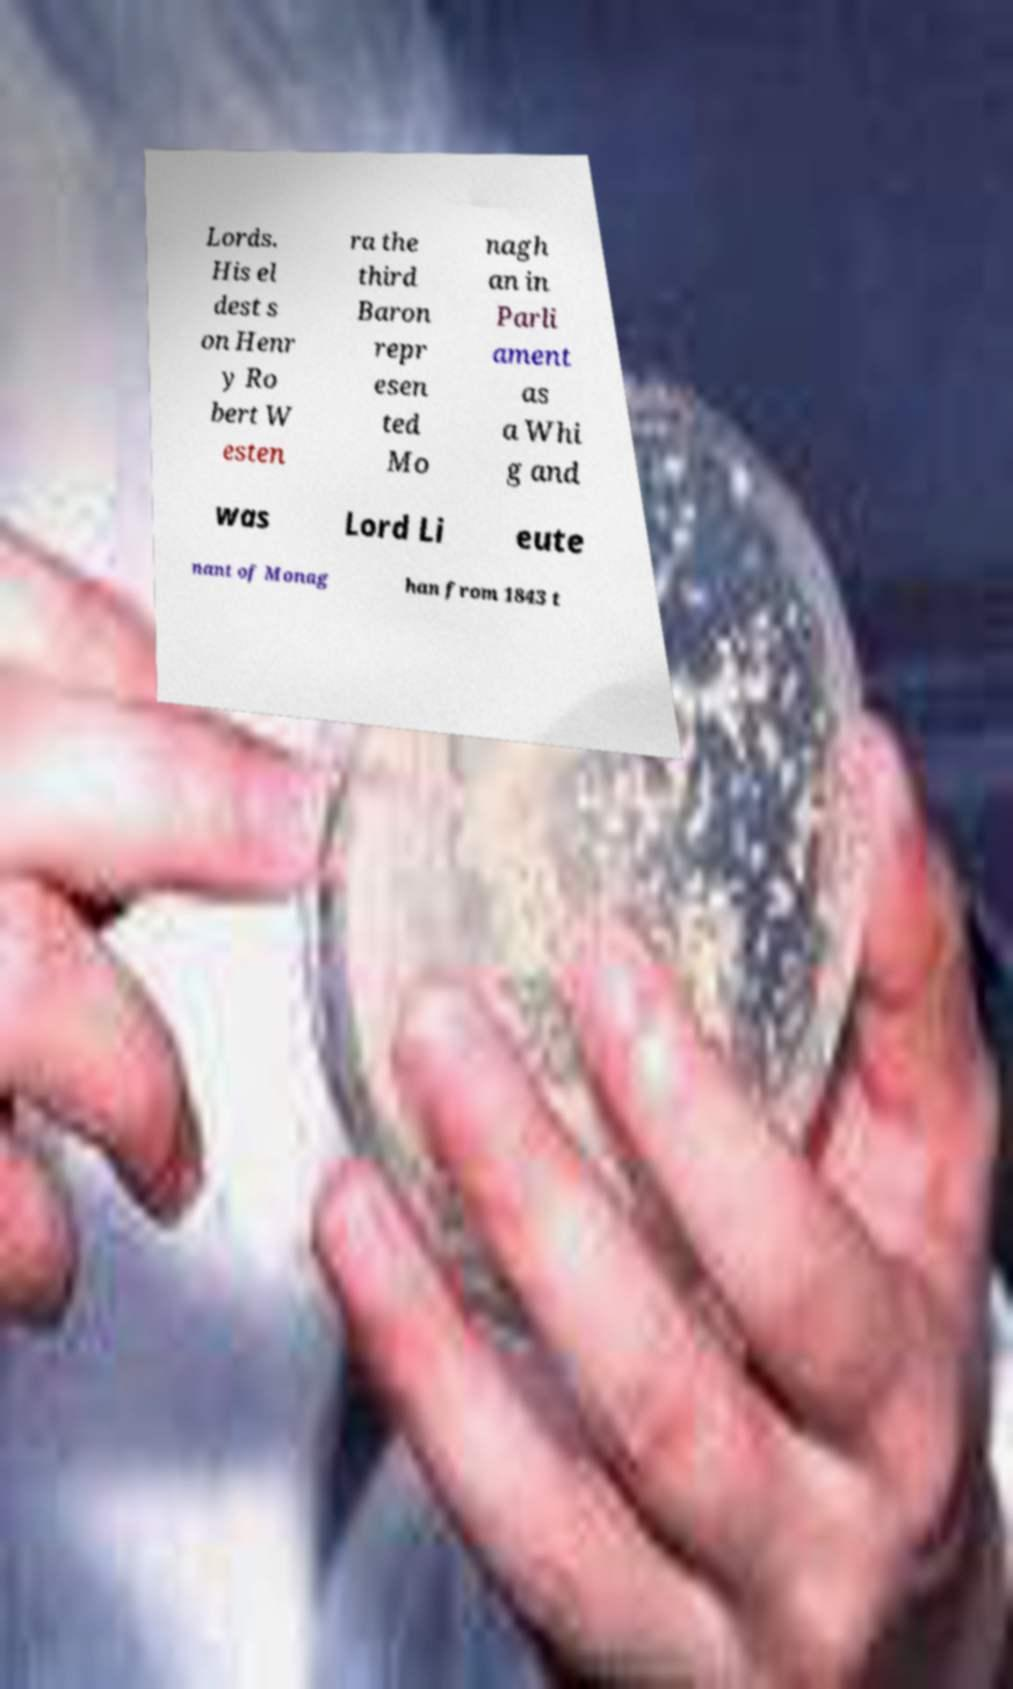What messages or text are displayed in this image? I need them in a readable, typed format. Lords. His el dest s on Henr y Ro bert W esten ra the third Baron repr esen ted Mo nagh an in Parli ament as a Whi g and was Lord Li eute nant of Monag han from 1843 t 